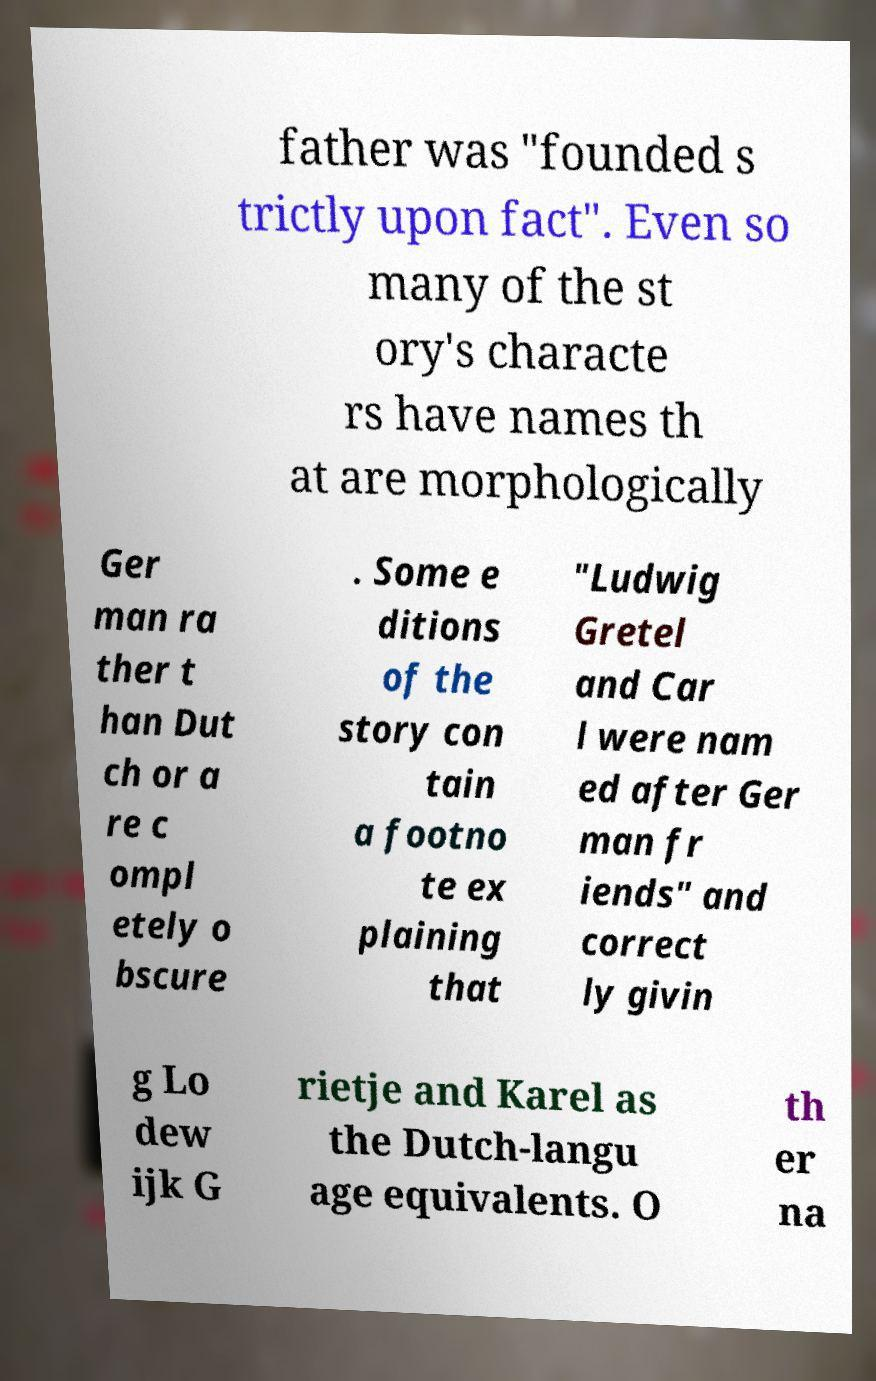Could you extract and type out the text from this image? father was "founded s trictly upon fact". Even so many of the st ory's characte rs have names th at are morphologically Ger man ra ther t han Dut ch or a re c ompl etely o bscure . Some e ditions of the story con tain a footno te ex plaining that "Ludwig Gretel and Car l were nam ed after Ger man fr iends" and correct ly givin g Lo dew ijk G rietje and Karel as the Dutch-langu age equivalents. O th er na 